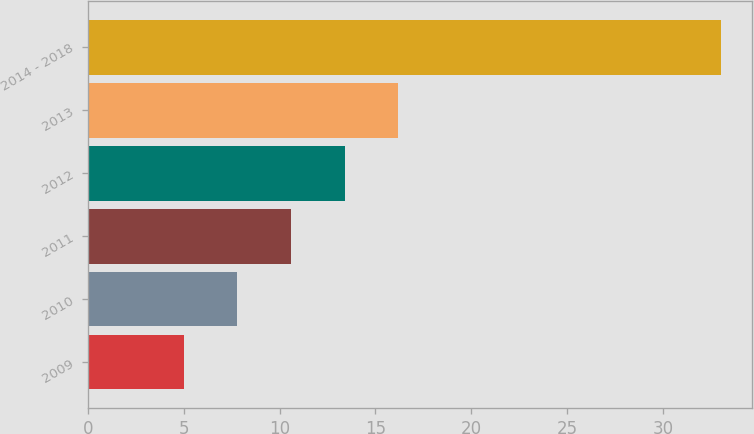Convert chart to OTSL. <chart><loc_0><loc_0><loc_500><loc_500><bar_chart><fcel>2009<fcel>2010<fcel>2011<fcel>2012<fcel>2013<fcel>2014 - 2018<nl><fcel>5<fcel>7.8<fcel>10.6<fcel>13.4<fcel>16.2<fcel>33<nl></chart> 